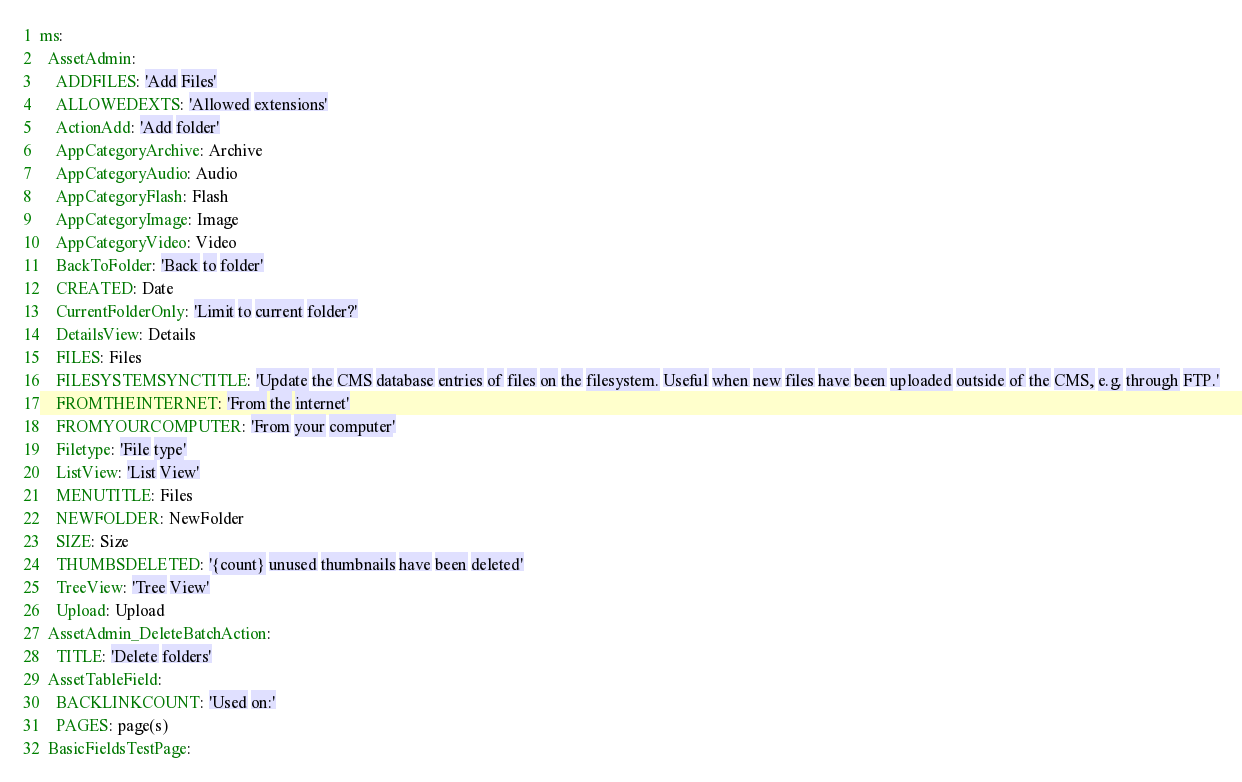<code> <loc_0><loc_0><loc_500><loc_500><_YAML_>ms:
  AssetAdmin:
    ADDFILES: 'Add Files'
    ALLOWEDEXTS: 'Allowed extensions'
    ActionAdd: 'Add folder'
    AppCategoryArchive: Archive
    AppCategoryAudio: Audio
    AppCategoryFlash: Flash
    AppCategoryImage: Image
    AppCategoryVideo: Video
    BackToFolder: 'Back to folder'
    CREATED: Date
    CurrentFolderOnly: 'Limit to current folder?'
    DetailsView: Details
    FILES: Files
    FILESYSTEMSYNCTITLE: 'Update the CMS database entries of files on the filesystem. Useful when new files have been uploaded outside of the CMS, e.g. through FTP.'
    FROMTHEINTERNET: 'From the internet'
    FROMYOURCOMPUTER: 'From your computer'
    Filetype: 'File type'
    ListView: 'List View'
    MENUTITLE: Files
    NEWFOLDER: NewFolder
    SIZE: Size
    THUMBSDELETED: '{count} unused thumbnails have been deleted'
    TreeView: 'Tree View'
    Upload: Upload
  AssetAdmin_DeleteBatchAction:
    TITLE: 'Delete folders'
  AssetTableField:
    BACKLINKCOUNT: 'Used on:'
    PAGES: page(s)
  BasicFieldsTestPage:</code> 